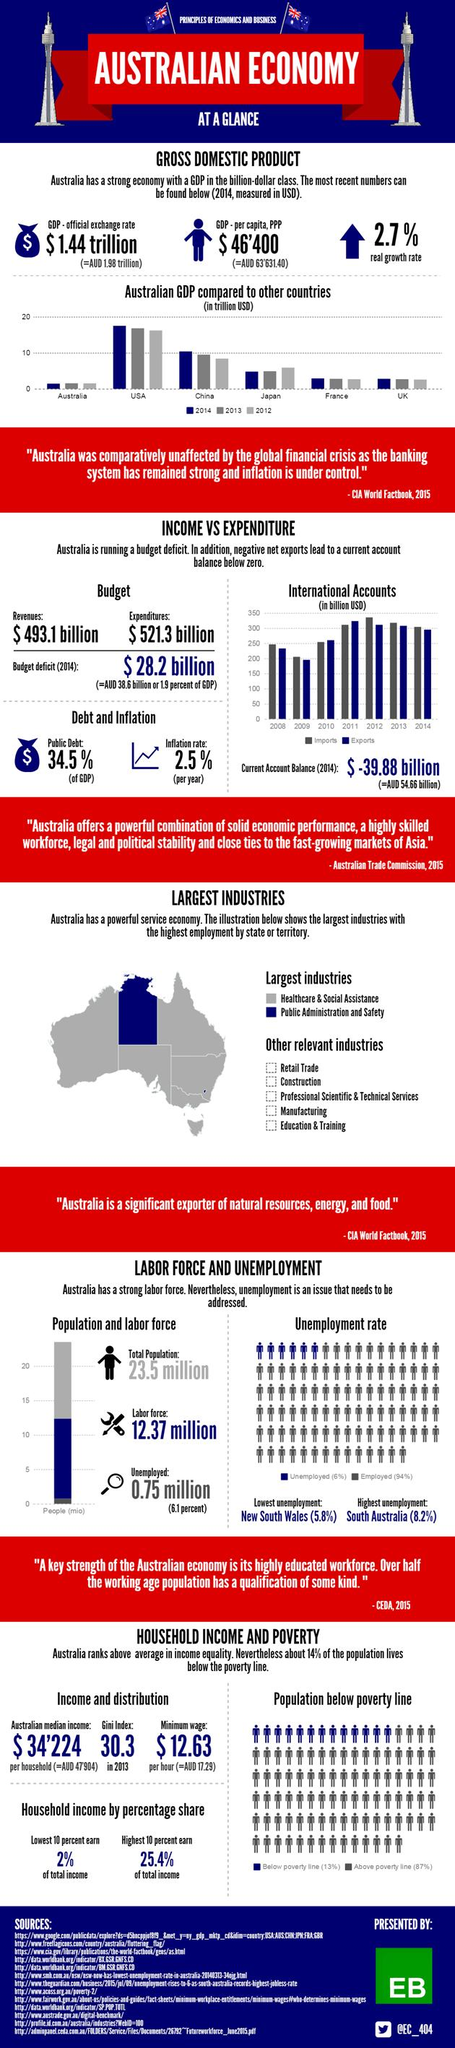Identify some key points in this picture. The bar chart shows the GDP of several countries in the year 2014, with the United States having the highest GDP. I see that 13 sources are listed at the bottom. The Twitter handle mentioned is @EC\_404. In 2012, imports reached their maximum under international accounts. In 2014, the Gross Domestic Product (GDP) of China reached 10 trillion US dollars, reflecting the significant economic growth and development of the country. 